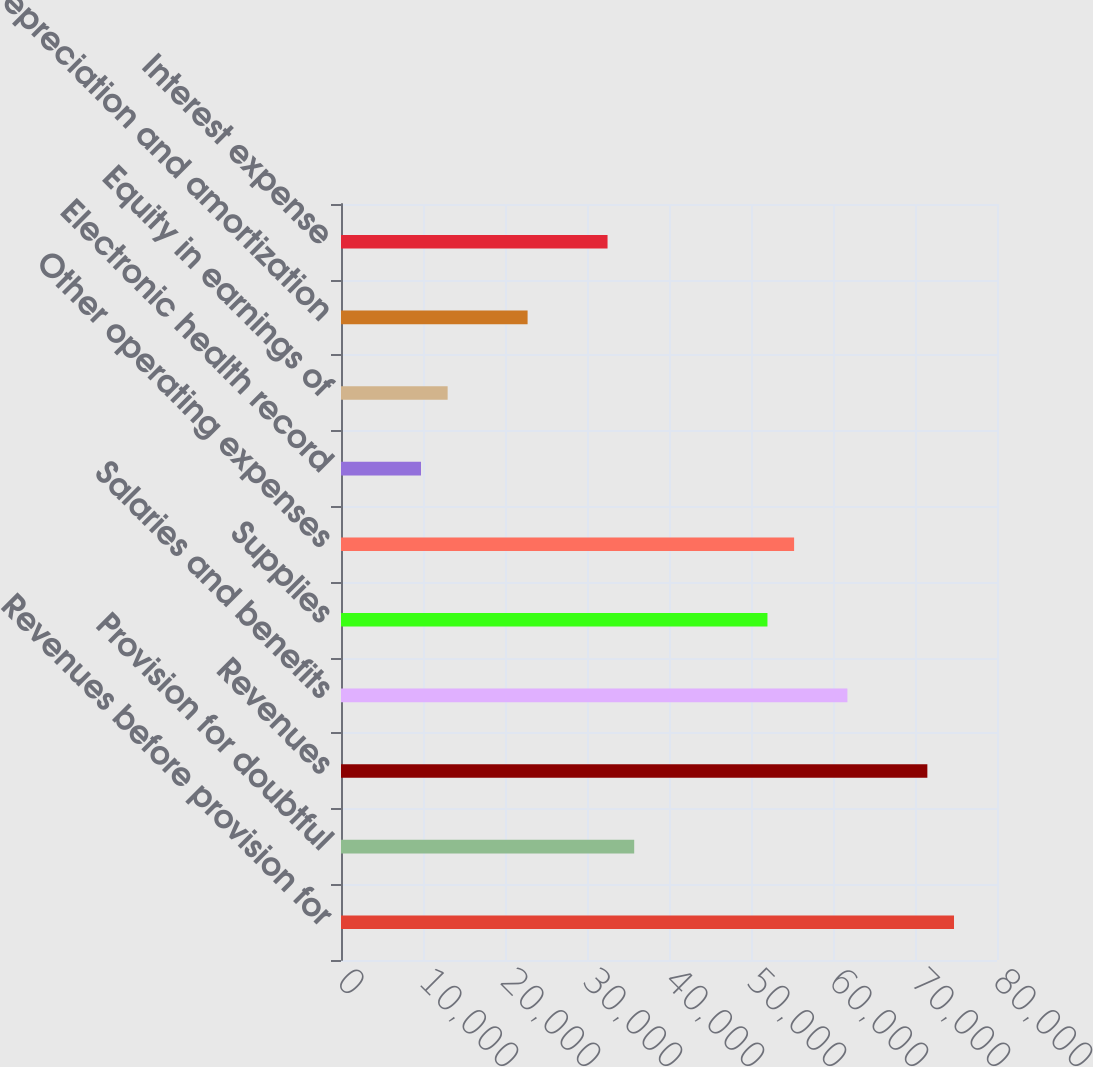Convert chart. <chart><loc_0><loc_0><loc_500><loc_500><bar_chart><fcel>Revenues before provision for<fcel>Provision for doubtful<fcel>Revenues<fcel>Salaries and benefits<fcel>Supplies<fcel>Other operating expenses<fcel>Electronic health record<fcel>Equity in earnings of<fcel>Depreciation and amortization<fcel>Interest expense<nl><fcel>74757.3<fcel>35756.1<fcel>71507.2<fcel>61756.9<fcel>52006.6<fcel>55256.7<fcel>9755.27<fcel>13005.4<fcel>22755.7<fcel>32506<nl></chart> 